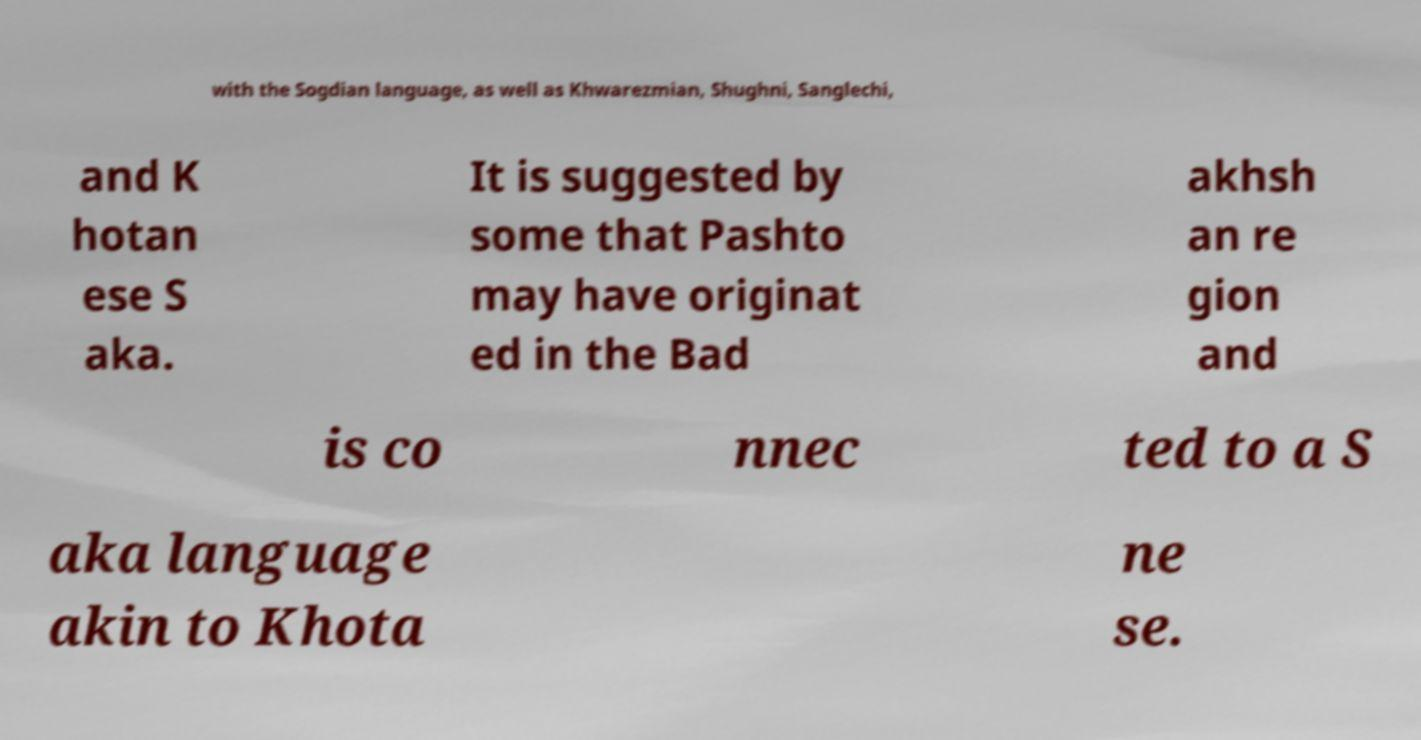Please read and relay the text visible in this image. What does it say? with the Sogdian language, as well as Khwarezmian, Shughni, Sanglechi, and K hotan ese S aka. It is suggested by some that Pashto may have originat ed in the Bad akhsh an re gion and is co nnec ted to a S aka language akin to Khota ne se. 